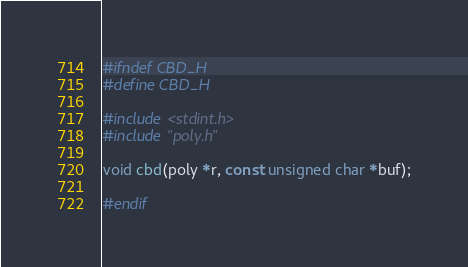<code> <loc_0><loc_0><loc_500><loc_500><_C_>#ifndef CBD_H
#define CBD_H

#include <stdint.h>
#include "poly.h"

void cbd(poly *r, const unsigned char *buf);

#endif
</code> 